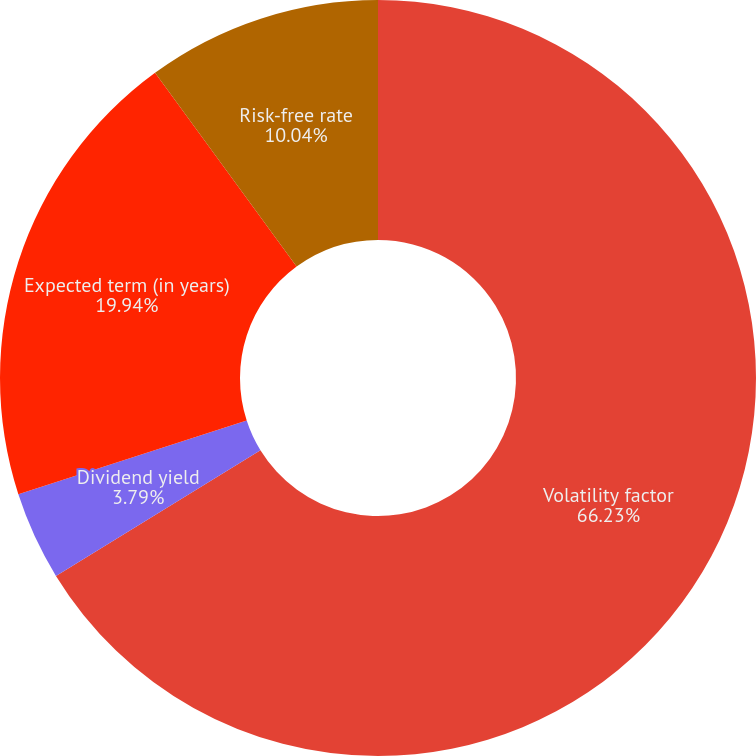Convert chart to OTSL. <chart><loc_0><loc_0><loc_500><loc_500><pie_chart><fcel>Volatility factor<fcel>Dividend yield<fcel>Expected term (in years)<fcel>Risk-free rate<nl><fcel>66.23%<fcel>3.79%<fcel>19.94%<fcel>10.04%<nl></chart> 